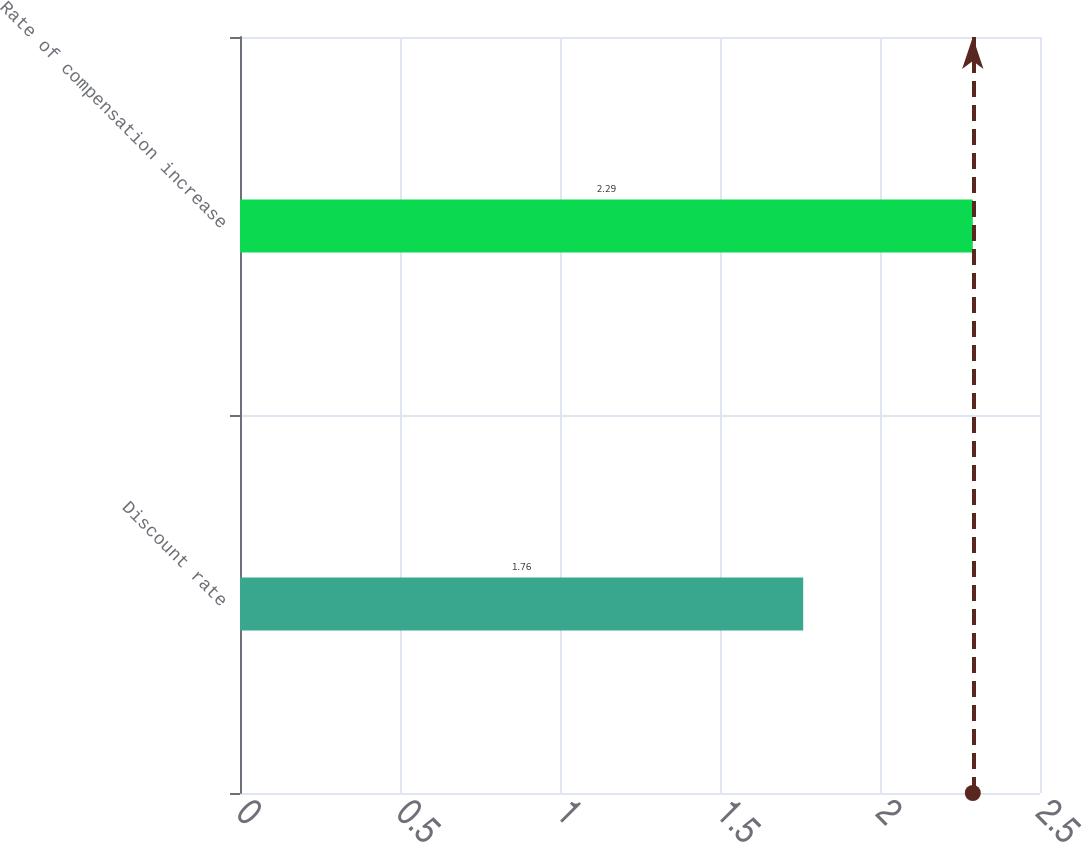Convert chart. <chart><loc_0><loc_0><loc_500><loc_500><bar_chart><fcel>Discount rate<fcel>Rate of compensation increase<nl><fcel>1.76<fcel>2.29<nl></chart> 